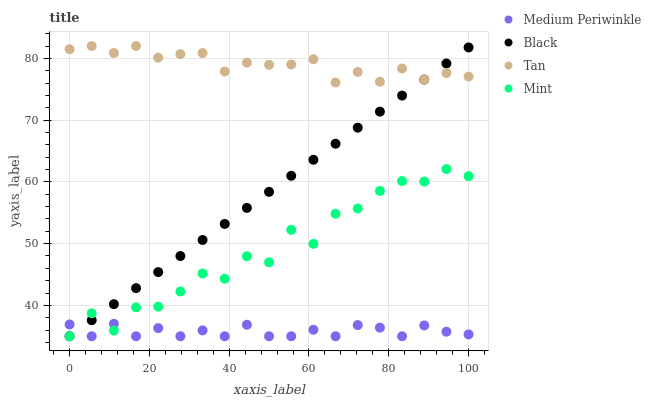Does Medium Periwinkle have the minimum area under the curve?
Answer yes or no. Yes. Does Tan have the maximum area under the curve?
Answer yes or no. Yes. Does Tan have the minimum area under the curve?
Answer yes or no. No. Does Medium Periwinkle have the maximum area under the curve?
Answer yes or no. No. Is Black the smoothest?
Answer yes or no. Yes. Is Mint the roughest?
Answer yes or no. Yes. Is Tan the smoothest?
Answer yes or no. No. Is Tan the roughest?
Answer yes or no. No. Does Black have the lowest value?
Answer yes or no. Yes. Does Tan have the lowest value?
Answer yes or no. No. Does Tan have the highest value?
Answer yes or no. Yes. Does Medium Periwinkle have the highest value?
Answer yes or no. No. Is Mint less than Tan?
Answer yes or no. Yes. Is Tan greater than Mint?
Answer yes or no. Yes. Does Black intersect Medium Periwinkle?
Answer yes or no. Yes. Is Black less than Medium Periwinkle?
Answer yes or no. No. Is Black greater than Medium Periwinkle?
Answer yes or no. No. Does Mint intersect Tan?
Answer yes or no. No. 